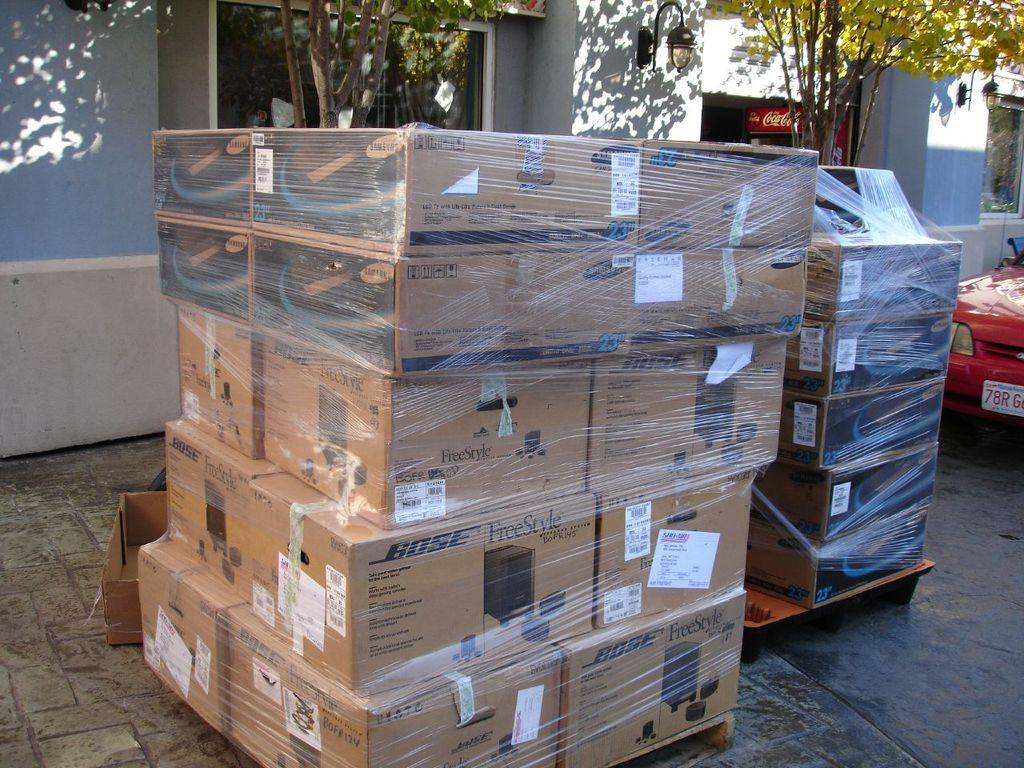<image>
Relay a brief, clear account of the picture shown. stacks of boxes with one of them labeled as 'bose' on the top left 